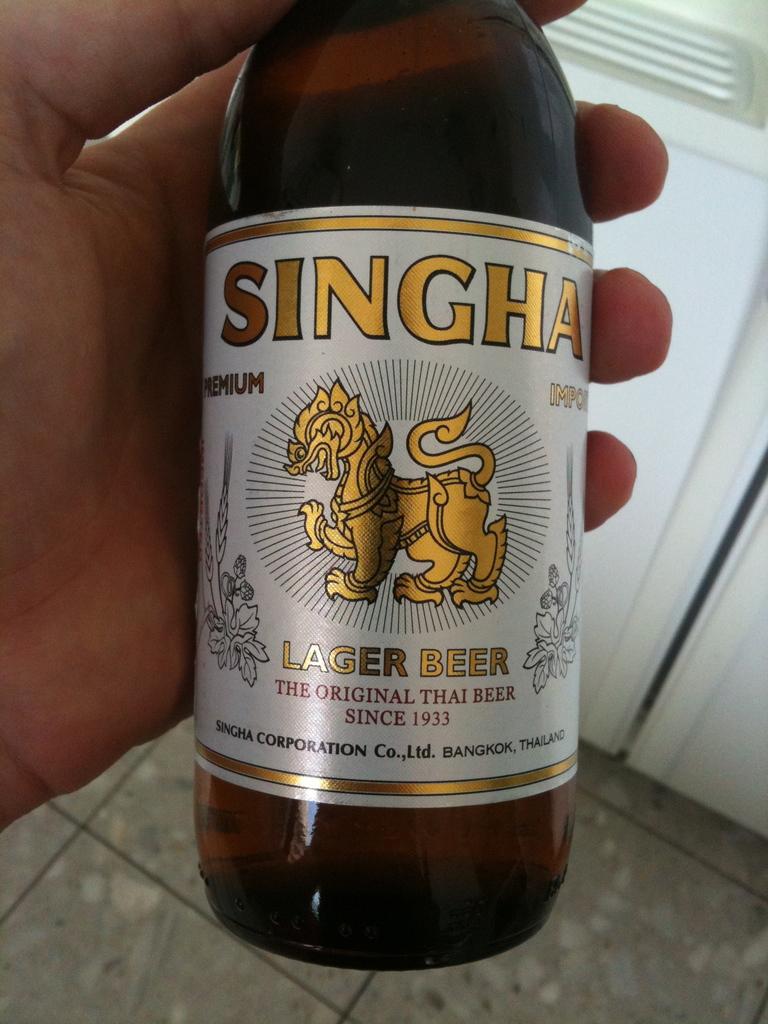What type of beer?
Provide a succinct answer. Lager. 